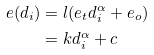Convert formula to latex. <formula><loc_0><loc_0><loc_500><loc_500>e ( d _ { i } ) & = l ( e _ { t } d _ { i } ^ { \alpha } + e _ { o } ) \\ & = k d _ { i } ^ { \alpha } + c</formula> 